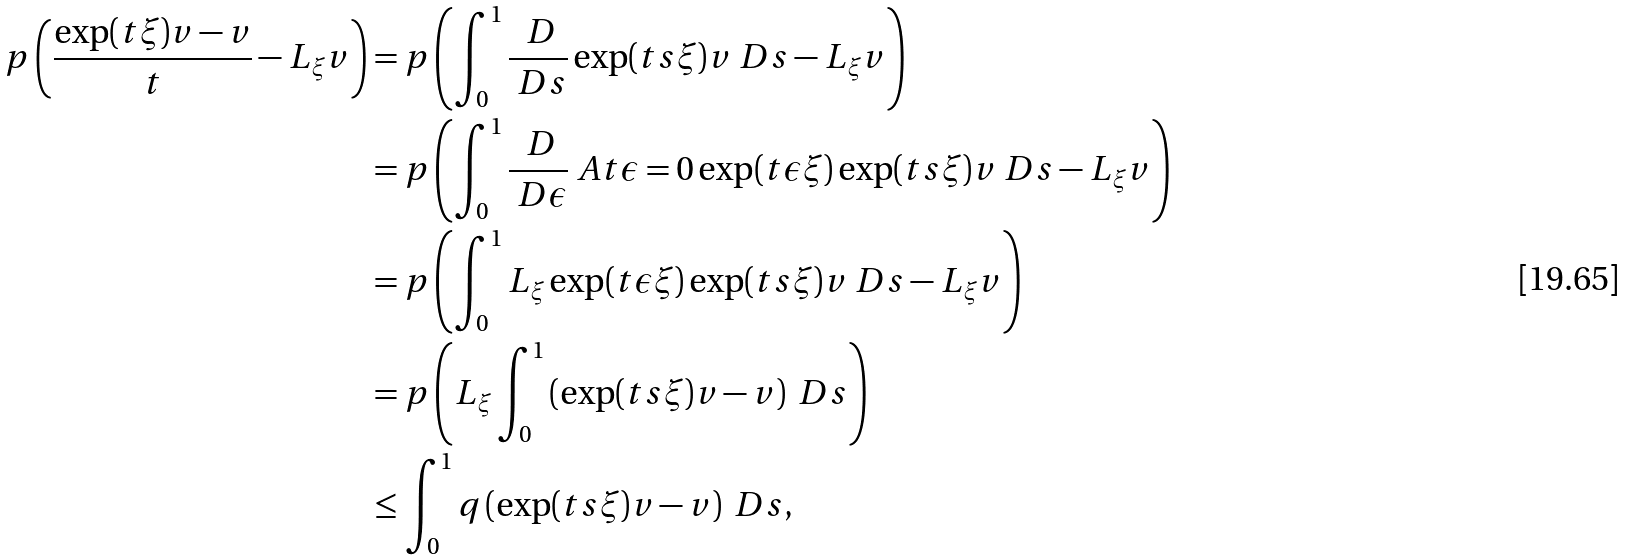Convert formula to latex. <formula><loc_0><loc_0><loc_500><loc_500>p \left ( \frac { \exp ( t \xi ) v - v } { t } - L _ { \xi } v \right ) & = p \left ( \int _ { 0 } ^ { 1 } \frac { \ D } { \ D s } \exp ( t s \xi ) v \ D s - L _ { \xi } v \right ) \\ & = p \left ( \int _ { 0 } ^ { 1 } \frac { \ D } { \ D \epsilon } \ A t { \epsilon = 0 } \exp ( t \epsilon \xi ) \exp ( t s \xi ) v \ D s - L _ { \xi } v \right ) \\ & = p \left ( \int _ { 0 } ^ { 1 } L _ { \xi } \exp ( t \epsilon \xi ) \exp ( t s \xi ) v \ D s - L _ { \xi } v \right ) \\ & = p \left ( L _ { \xi } \int _ { 0 } ^ { 1 } \left ( \exp ( t s \xi ) v - v \right ) \ D s \right ) \\ & \leq \int _ { 0 } ^ { 1 } q \left ( \exp ( t s \xi ) v - v \right ) \ D s ,</formula> 